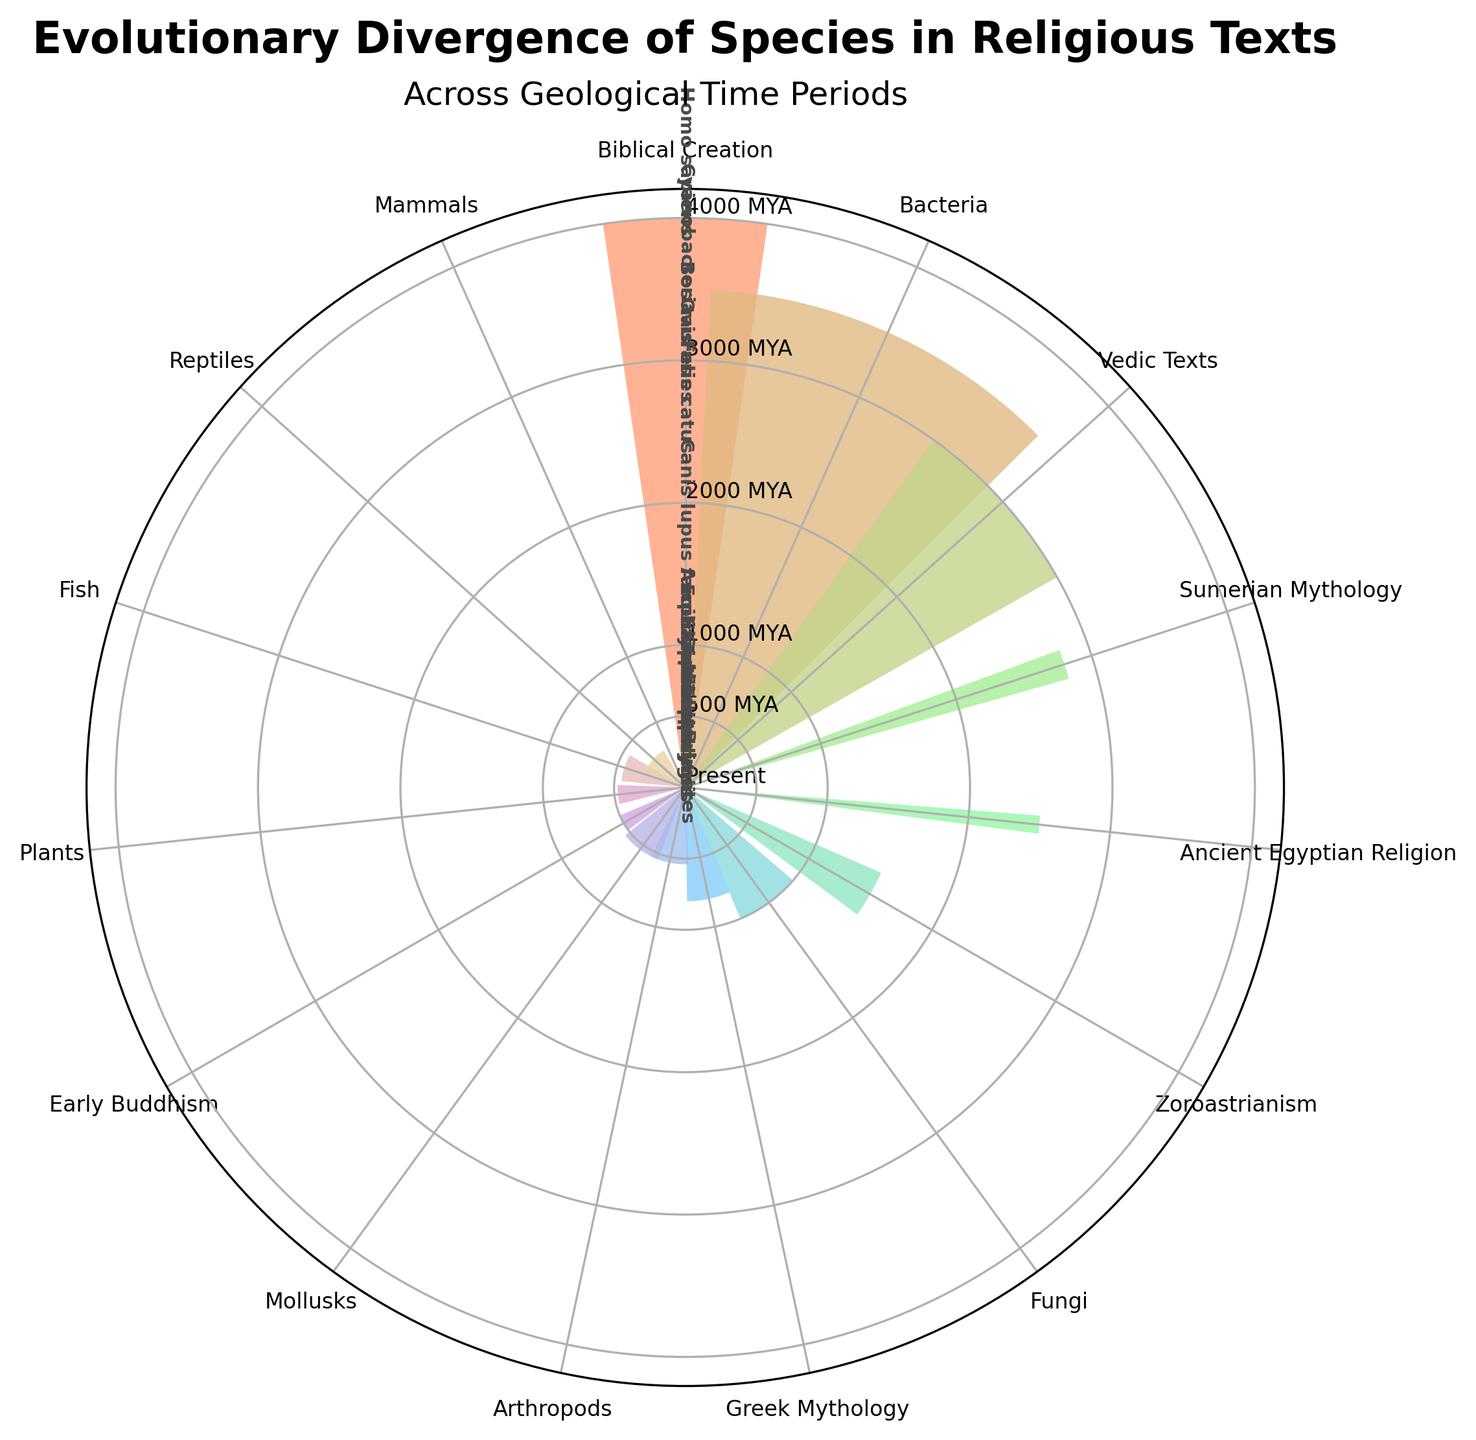Which species is associated with Greek Mythology? The label for Greek Mythology shows the species Equus caballus.
Answer: Equus caballus What is the oldest time period displayed on the chart? The furthest point from the center represents the oldest time period, which is 3500 million years ago for Bacteria.
Answer: 3500 million years ago Which religious text corresponds to Ovis aries? The label for Ovis aries is near Sumerian Mythology.
Answer: Sumerian Mythology Compare the divergence times of Primates and Insecta. Which is older? Primates diverged 65 million years ago, whereas Insecta diverged 540 million years ago. 540 million years ago is older.
Answer: Insecta How many species are represented in time periods before 1000 BCE? The species are Homo sapiens (Biblical Creation), Bos taurus (Vedic Texts), Ovis aries (Sumerian Mythology), Felis catus (Ancient Egyptian Religion), and Canis lupus familiaris (Zoroastrianism). There are 5 species in total.
Answer: 5 What time period does Cyanobacteria belong to? Cyanobacteria is labeled at the time period 3500 million years ago.
Answer: 3500 million years ago Which has more recent divergence, Elephas maximus or Felis catus? Elephas maximus in Early Buddhism is 500 BCE, whereas Felis catus in Ancient Egyptian Religion is 2500 BCE. 500 BCE is more recent.
Answer: Elephas maximus How many categories have time periods in the range of 500 MYA to 3000 MYA? Examining the chart, categories in this range are Mammals (65 MYA), Reptiles (300 MYA), Fish (450 MYA), and Plants (475 MYA). There are 4 categories.
Answer: 4 What is the title of the chart? The main title is "Evolutionary Divergence of Species in Religious Texts".
Answer: Evolutionary Divergence of Species in Religious Texts What is the position of Canis lupus familiaris in terms of time period compared to Equus caballus? Canis lupus familiaris (Zoroastrianism, 1500 BCE) is older than Equus caballus (Greek Mythology, 800 BCE).
Answer: Older 